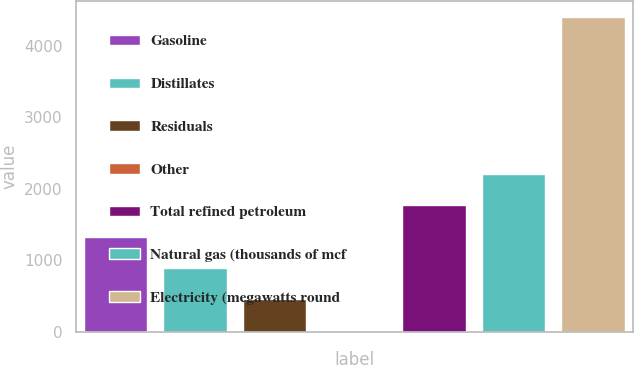Convert chart to OTSL. <chart><loc_0><loc_0><loc_500><loc_500><bar_chart><fcel>Gasoline<fcel>Distillates<fcel>Residuals<fcel>Other<fcel>Total refined petroleum<fcel>Natural gas (thousands of mcf<fcel>Electricity (megawatts round<nl><fcel>1334<fcel>896<fcel>458<fcel>20<fcel>1772<fcel>2210<fcel>4400<nl></chart> 